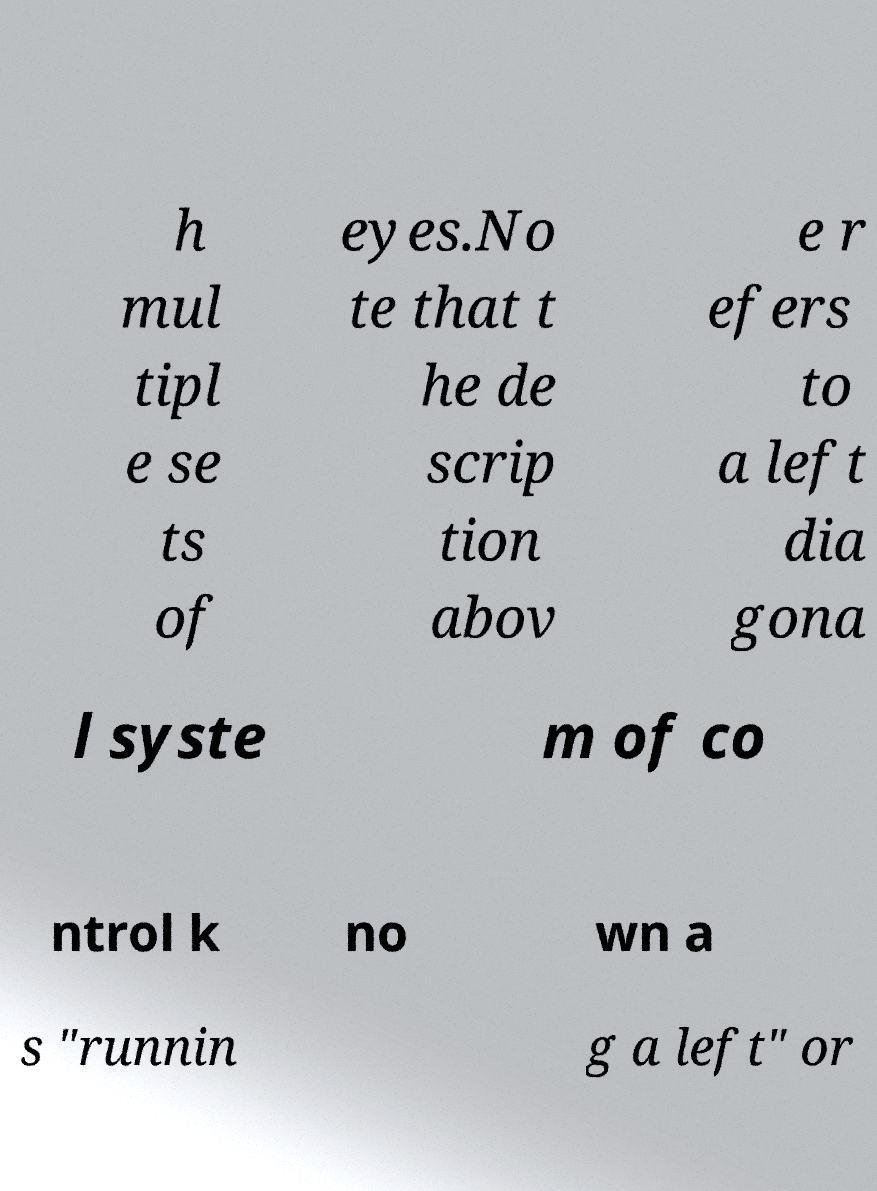Please read and relay the text visible in this image. What does it say? h mul tipl e se ts of eyes.No te that t he de scrip tion abov e r efers to a left dia gona l syste m of co ntrol k no wn a s "runnin g a left" or 